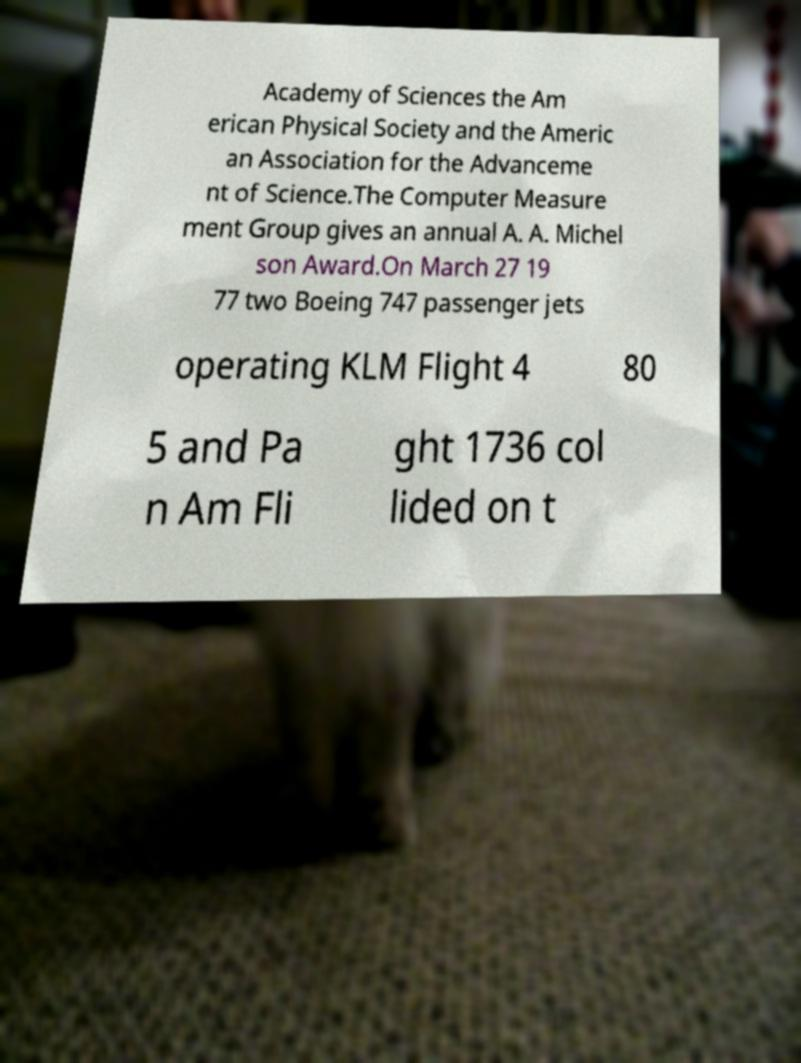Could you assist in decoding the text presented in this image and type it out clearly? Academy of Sciences the Am erican Physical Society and the Americ an Association for the Advanceme nt of Science.The Computer Measure ment Group gives an annual A. A. Michel son Award.On March 27 19 77 two Boeing 747 passenger jets operating KLM Flight 4 80 5 and Pa n Am Fli ght 1736 col lided on t 